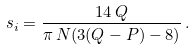<formula> <loc_0><loc_0><loc_500><loc_500>s _ { i } = \frac { 1 4 \, Q } { \pi \, N ( 3 ( Q - P ) - 8 ) } \, .</formula> 